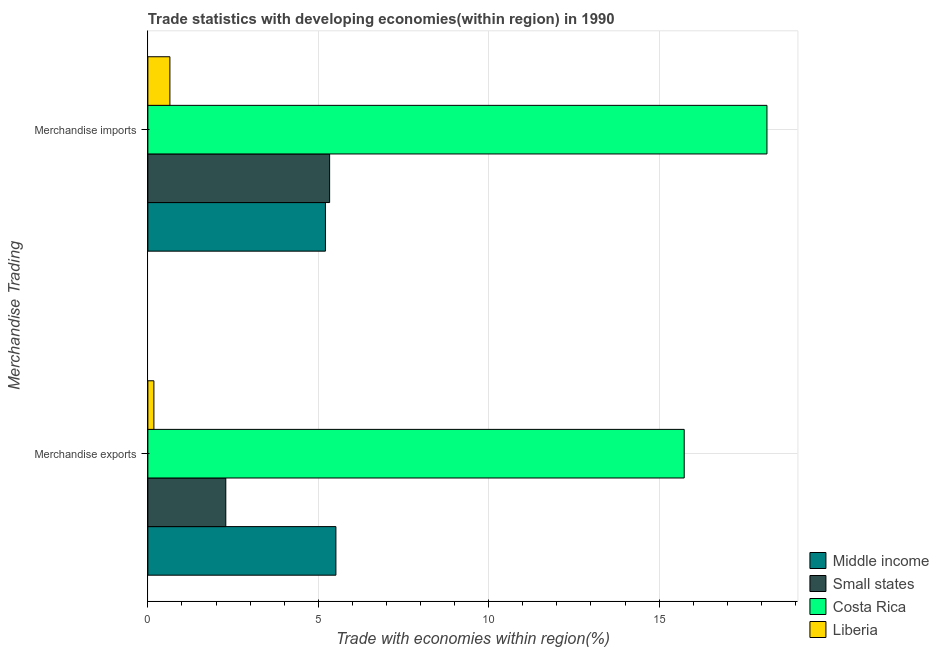How many different coloured bars are there?
Offer a terse response. 4. How many groups of bars are there?
Offer a very short reply. 2. How many bars are there on the 2nd tick from the top?
Your answer should be compact. 4. What is the merchandise exports in Middle income?
Offer a very short reply. 5.52. Across all countries, what is the maximum merchandise exports?
Your answer should be compact. 15.74. Across all countries, what is the minimum merchandise exports?
Provide a short and direct response. 0.18. In which country was the merchandise exports minimum?
Ensure brevity in your answer.  Liberia. What is the total merchandise exports in the graph?
Provide a succinct answer. 23.72. What is the difference between the merchandise exports in Middle income and that in Small states?
Give a very brief answer. 3.23. What is the difference between the merchandise imports in Costa Rica and the merchandise exports in Middle income?
Offer a very short reply. 12.65. What is the average merchandise exports per country?
Your answer should be compact. 5.93. What is the difference between the merchandise imports and merchandise exports in Costa Rica?
Your response must be concise. 2.43. What is the ratio of the merchandise imports in Costa Rica to that in Liberia?
Offer a terse response. 28.11. Is the merchandise imports in Small states less than that in Middle income?
Offer a very short reply. No. In how many countries, is the merchandise exports greater than the average merchandise exports taken over all countries?
Keep it short and to the point. 1. What does the 3rd bar from the top in Merchandise imports represents?
Your answer should be very brief. Small states. What does the 2nd bar from the bottom in Merchandise exports represents?
Offer a terse response. Small states. Are all the bars in the graph horizontal?
Your answer should be compact. Yes. Are the values on the major ticks of X-axis written in scientific E-notation?
Give a very brief answer. No. Does the graph contain any zero values?
Your response must be concise. No. Does the graph contain grids?
Your response must be concise. Yes. How many legend labels are there?
Provide a short and direct response. 4. What is the title of the graph?
Keep it short and to the point. Trade statistics with developing economies(within region) in 1990. What is the label or title of the X-axis?
Offer a very short reply. Trade with economies within region(%). What is the label or title of the Y-axis?
Provide a succinct answer. Merchandise Trading. What is the Trade with economies within region(%) in Middle income in Merchandise exports?
Provide a succinct answer. 5.52. What is the Trade with economies within region(%) of Small states in Merchandise exports?
Ensure brevity in your answer.  2.29. What is the Trade with economies within region(%) of Costa Rica in Merchandise exports?
Ensure brevity in your answer.  15.74. What is the Trade with economies within region(%) of Liberia in Merchandise exports?
Make the answer very short. 0.18. What is the Trade with economies within region(%) in Middle income in Merchandise imports?
Make the answer very short. 5.21. What is the Trade with economies within region(%) of Small states in Merchandise imports?
Ensure brevity in your answer.  5.33. What is the Trade with economies within region(%) of Costa Rica in Merchandise imports?
Keep it short and to the point. 18.16. What is the Trade with economies within region(%) in Liberia in Merchandise imports?
Your answer should be compact. 0.65. Across all Merchandise Trading, what is the maximum Trade with economies within region(%) of Middle income?
Offer a terse response. 5.52. Across all Merchandise Trading, what is the maximum Trade with economies within region(%) in Small states?
Offer a very short reply. 5.33. Across all Merchandise Trading, what is the maximum Trade with economies within region(%) of Costa Rica?
Make the answer very short. 18.16. Across all Merchandise Trading, what is the maximum Trade with economies within region(%) in Liberia?
Ensure brevity in your answer.  0.65. Across all Merchandise Trading, what is the minimum Trade with economies within region(%) of Middle income?
Offer a very short reply. 5.21. Across all Merchandise Trading, what is the minimum Trade with economies within region(%) in Small states?
Offer a terse response. 2.29. Across all Merchandise Trading, what is the minimum Trade with economies within region(%) of Costa Rica?
Your answer should be very brief. 15.74. Across all Merchandise Trading, what is the minimum Trade with economies within region(%) in Liberia?
Offer a very short reply. 0.18. What is the total Trade with economies within region(%) in Middle income in the graph?
Keep it short and to the point. 10.73. What is the total Trade with economies within region(%) of Small states in the graph?
Your answer should be compact. 7.62. What is the total Trade with economies within region(%) in Costa Rica in the graph?
Your answer should be very brief. 33.9. What is the total Trade with economies within region(%) of Liberia in the graph?
Provide a succinct answer. 0.82. What is the difference between the Trade with economies within region(%) in Middle income in Merchandise exports and that in Merchandise imports?
Your answer should be very brief. 0.31. What is the difference between the Trade with economies within region(%) in Small states in Merchandise exports and that in Merchandise imports?
Give a very brief answer. -3.05. What is the difference between the Trade with economies within region(%) in Costa Rica in Merchandise exports and that in Merchandise imports?
Ensure brevity in your answer.  -2.43. What is the difference between the Trade with economies within region(%) of Liberia in Merchandise exports and that in Merchandise imports?
Keep it short and to the point. -0.47. What is the difference between the Trade with economies within region(%) of Middle income in Merchandise exports and the Trade with economies within region(%) of Small states in Merchandise imports?
Ensure brevity in your answer.  0.18. What is the difference between the Trade with economies within region(%) of Middle income in Merchandise exports and the Trade with economies within region(%) of Costa Rica in Merchandise imports?
Give a very brief answer. -12.65. What is the difference between the Trade with economies within region(%) in Middle income in Merchandise exports and the Trade with economies within region(%) in Liberia in Merchandise imports?
Make the answer very short. 4.87. What is the difference between the Trade with economies within region(%) in Small states in Merchandise exports and the Trade with economies within region(%) in Costa Rica in Merchandise imports?
Your answer should be very brief. -15.88. What is the difference between the Trade with economies within region(%) of Small states in Merchandise exports and the Trade with economies within region(%) of Liberia in Merchandise imports?
Your answer should be very brief. 1.64. What is the difference between the Trade with economies within region(%) of Costa Rica in Merchandise exports and the Trade with economies within region(%) of Liberia in Merchandise imports?
Your response must be concise. 15.09. What is the average Trade with economies within region(%) in Middle income per Merchandise Trading?
Your answer should be compact. 5.36. What is the average Trade with economies within region(%) in Small states per Merchandise Trading?
Your response must be concise. 3.81. What is the average Trade with economies within region(%) of Costa Rica per Merchandise Trading?
Keep it short and to the point. 16.95. What is the average Trade with economies within region(%) of Liberia per Merchandise Trading?
Keep it short and to the point. 0.41. What is the difference between the Trade with economies within region(%) in Middle income and Trade with economies within region(%) in Small states in Merchandise exports?
Offer a very short reply. 3.23. What is the difference between the Trade with economies within region(%) in Middle income and Trade with economies within region(%) in Costa Rica in Merchandise exports?
Your answer should be compact. -10.22. What is the difference between the Trade with economies within region(%) of Middle income and Trade with economies within region(%) of Liberia in Merchandise exports?
Your response must be concise. 5.34. What is the difference between the Trade with economies within region(%) in Small states and Trade with economies within region(%) in Costa Rica in Merchandise exports?
Your answer should be compact. -13.45. What is the difference between the Trade with economies within region(%) of Small states and Trade with economies within region(%) of Liberia in Merchandise exports?
Your response must be concise. 2.11. What is the difference between the Trade with economies within region(%) of Costa Rica and Trade with economies within region(%) of Liberia in Merchandise exports?
Provide a short and direct response. 15.56. What is the difference between the Trade with economies within region(%) of Middle income and Trade with economies within region(%) of Small states in Merchandise imports?
Provide a succinct answer. -0.12. What is the difference between the Trade with economies within region(%) of Middle income and Trade with economies within region(%) of Costa Rica in Merchandise imports?
Provide a succinct answer. -12.95. What is the difference between the Trade with economies within region(%) of Middle income and Trade with economies within region(%) of Liberia in Merchandise imports?
Your response must be concise. 4.56. What is the difference between the Trade with economies within region(%) in Small states and Trade with economies within region(%) in Costa Rica in Merchandise imports?
Offer a terse response. -12.83. What is the difference between the Trade with economies within region(%) of Small states and Trade with economies within region(%) of Liberia in Merchandise imports?
Give a very brief answer. 4.69. What is the difference between the Trade with economies within region(%) of Costa Rica and Trade with economies within region(%) of Liberia in Merchandise imports?
Provide a short and direct response. 17.52. What is the ratio of the Trade with economies within region(%) of Middle income in Merchandise exports to that in Merchandise imports?
Offer a very short reply. 1.06. What is the ratio of the Trade with economies within region(%) in Small states in Merchandise exports to that in Merchandise imports?
Provide a short and direct response. 0.43. What is the ratio of the Trade with economies within region(%) of Costa Rica in Merchandise exports to that in Merchandise imports?
Ensure brevity in your answer.  0.87. What is the ratio of the Trade with economies within region(%) in Liberia in Merchandise exports to that in Merchandise imports?
Provide a short and direct response. 0.27. What is the difference between the highest and the second highest Trade with economies within region(%) in Middle income?
Make the answer very short. 0.31. What is the difference between the highest and the second highest Trade with economies within region(%) of Small states?
Give a very brief answer. 3.05. What is the difference between the highest and the second highest Trade with economies within region(%) in Costa Rica?
Offer a terse response. 2.43. What is the difference between the highest and the second highest Trade with economies within region(%) of Liberia?
Provide a succinct answer. 0.47. What is the difference between the highest and the lowest Trade with economies within region(%) of Middle income?
Ensure brevity in your answer.  0.31. What is the difference between the highest and the lowest Trade with economies within region(%) in Small states?
Make the answer very short. 3.05. What is the difference between the highest and the lowest Trade with economies within region(%) in Costa Rica?
Give a very brief answer. 2.43. What is the difference between the highest and the lowest Trade with economies within region(%) of Liberia?
Your answer should be compact. 0.47. 